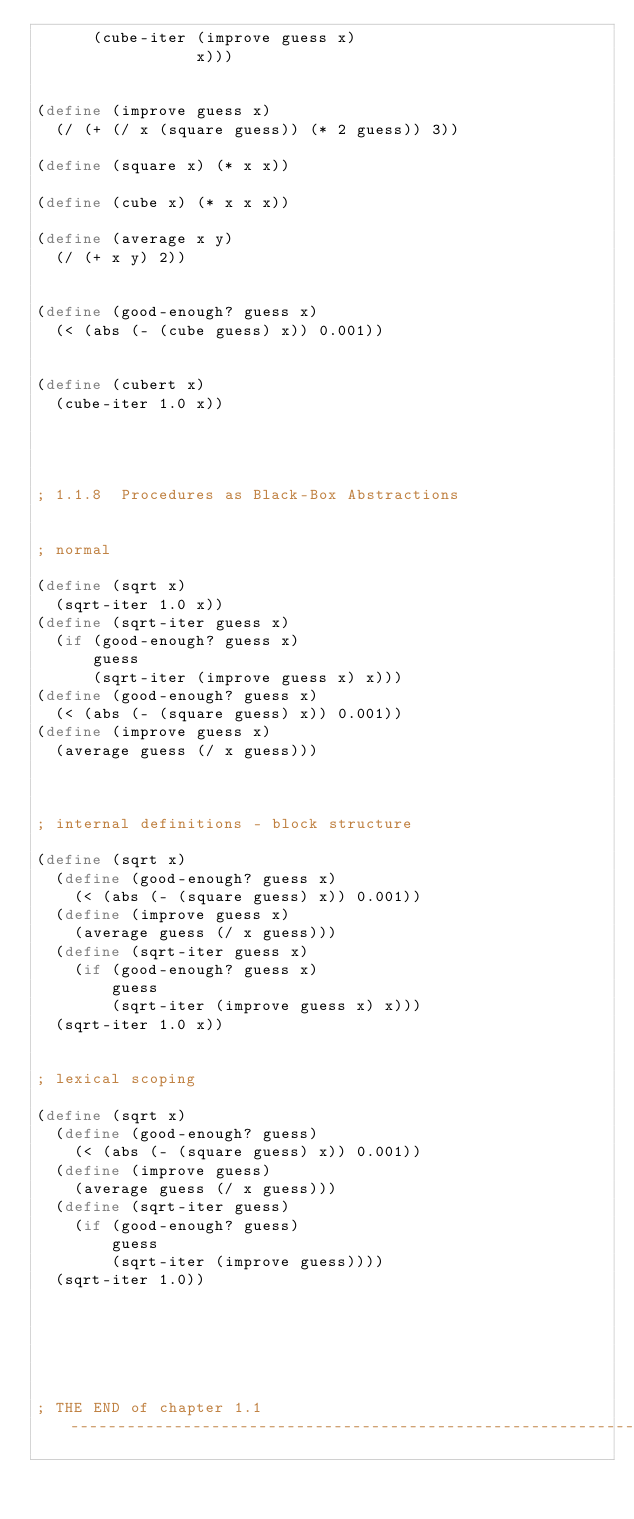<code> <loc_0><loc_0><loc_500><loc_500><_Scheme_>      (cube-iter (improve guess x)
                 x)))


(define (improve guess x)
  (/ (+ (/ x (square guess)) (* 2 guess)) 3))

(define (square x) (* x x)) 

(define (cube x) (* x x x))

(define (average x y)
  (/ (+ x y) 2))


(define (good-enough? guess x)
  (< (abs (- (cube guess) x)) 0.001))


(define (cubert x)
  (cube-iter 1.0 x))




; 1.1.8  Procedures as Black-Box Abstractions


; normal 

(define (sqrt x)
  (sqrt-iter 1.0 x))
(define (sqrt-iter guess x)
  (if (good-enough? guess x)
      guess
      (sqrt-iter (improve guess x) x)))
(define (good-enough? guess x)
  (< (abs (- (square guess) x)) 0.001))
(define (improve guess x)
  (average guess (/ x guess)))



; internal definitions - block structure

(define (sqrt x)
  (define (good-enough? guess x)
    (< (abs (- (square guess) x)) 0.001))
  (define (improve guess x)
    (average guess (/ x guess)))
  (define (sqrt-iter guess x)
    (if (good-enough? guess x)
        guess
        (sqrt-iter (improve guess x) x)))
  (sqrt-iter 1.0 x))


; lexical scoping

(define (sqrt x)
  (define (good-enough? guess)
    (< (abs (- (square guess) x)) 0.001))
  (define (improve guess)
    (average guess (/ x guess)))
  (define (sqrt-iter guess)
    (if (good-enough? guess)
        guess
        (sqrt-iter (improve guess))))
  (sqrt-iter 1.0))






; THE END of chapter 1.1 -------------------------------------------------------------------</code> 